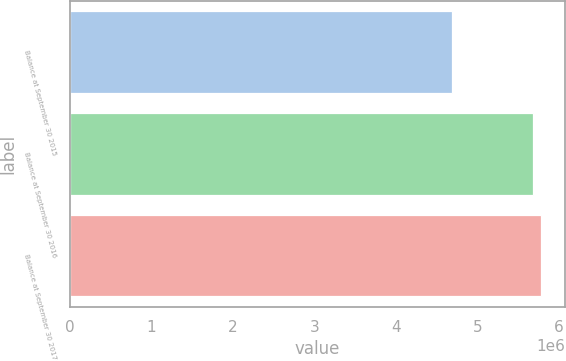Convert chart to OTSL. <chart><loc_0><loc_0><loc_500><loc_500><bar_chart><fcel>Balance at September 30 2015<fcel>Balance at September 30 2016<fcel>Balance at September 30 2017<nl><fcel>4.68622e+06<fcel>5.67945e+06<fcel>5.78536e+06<nl></chart> 